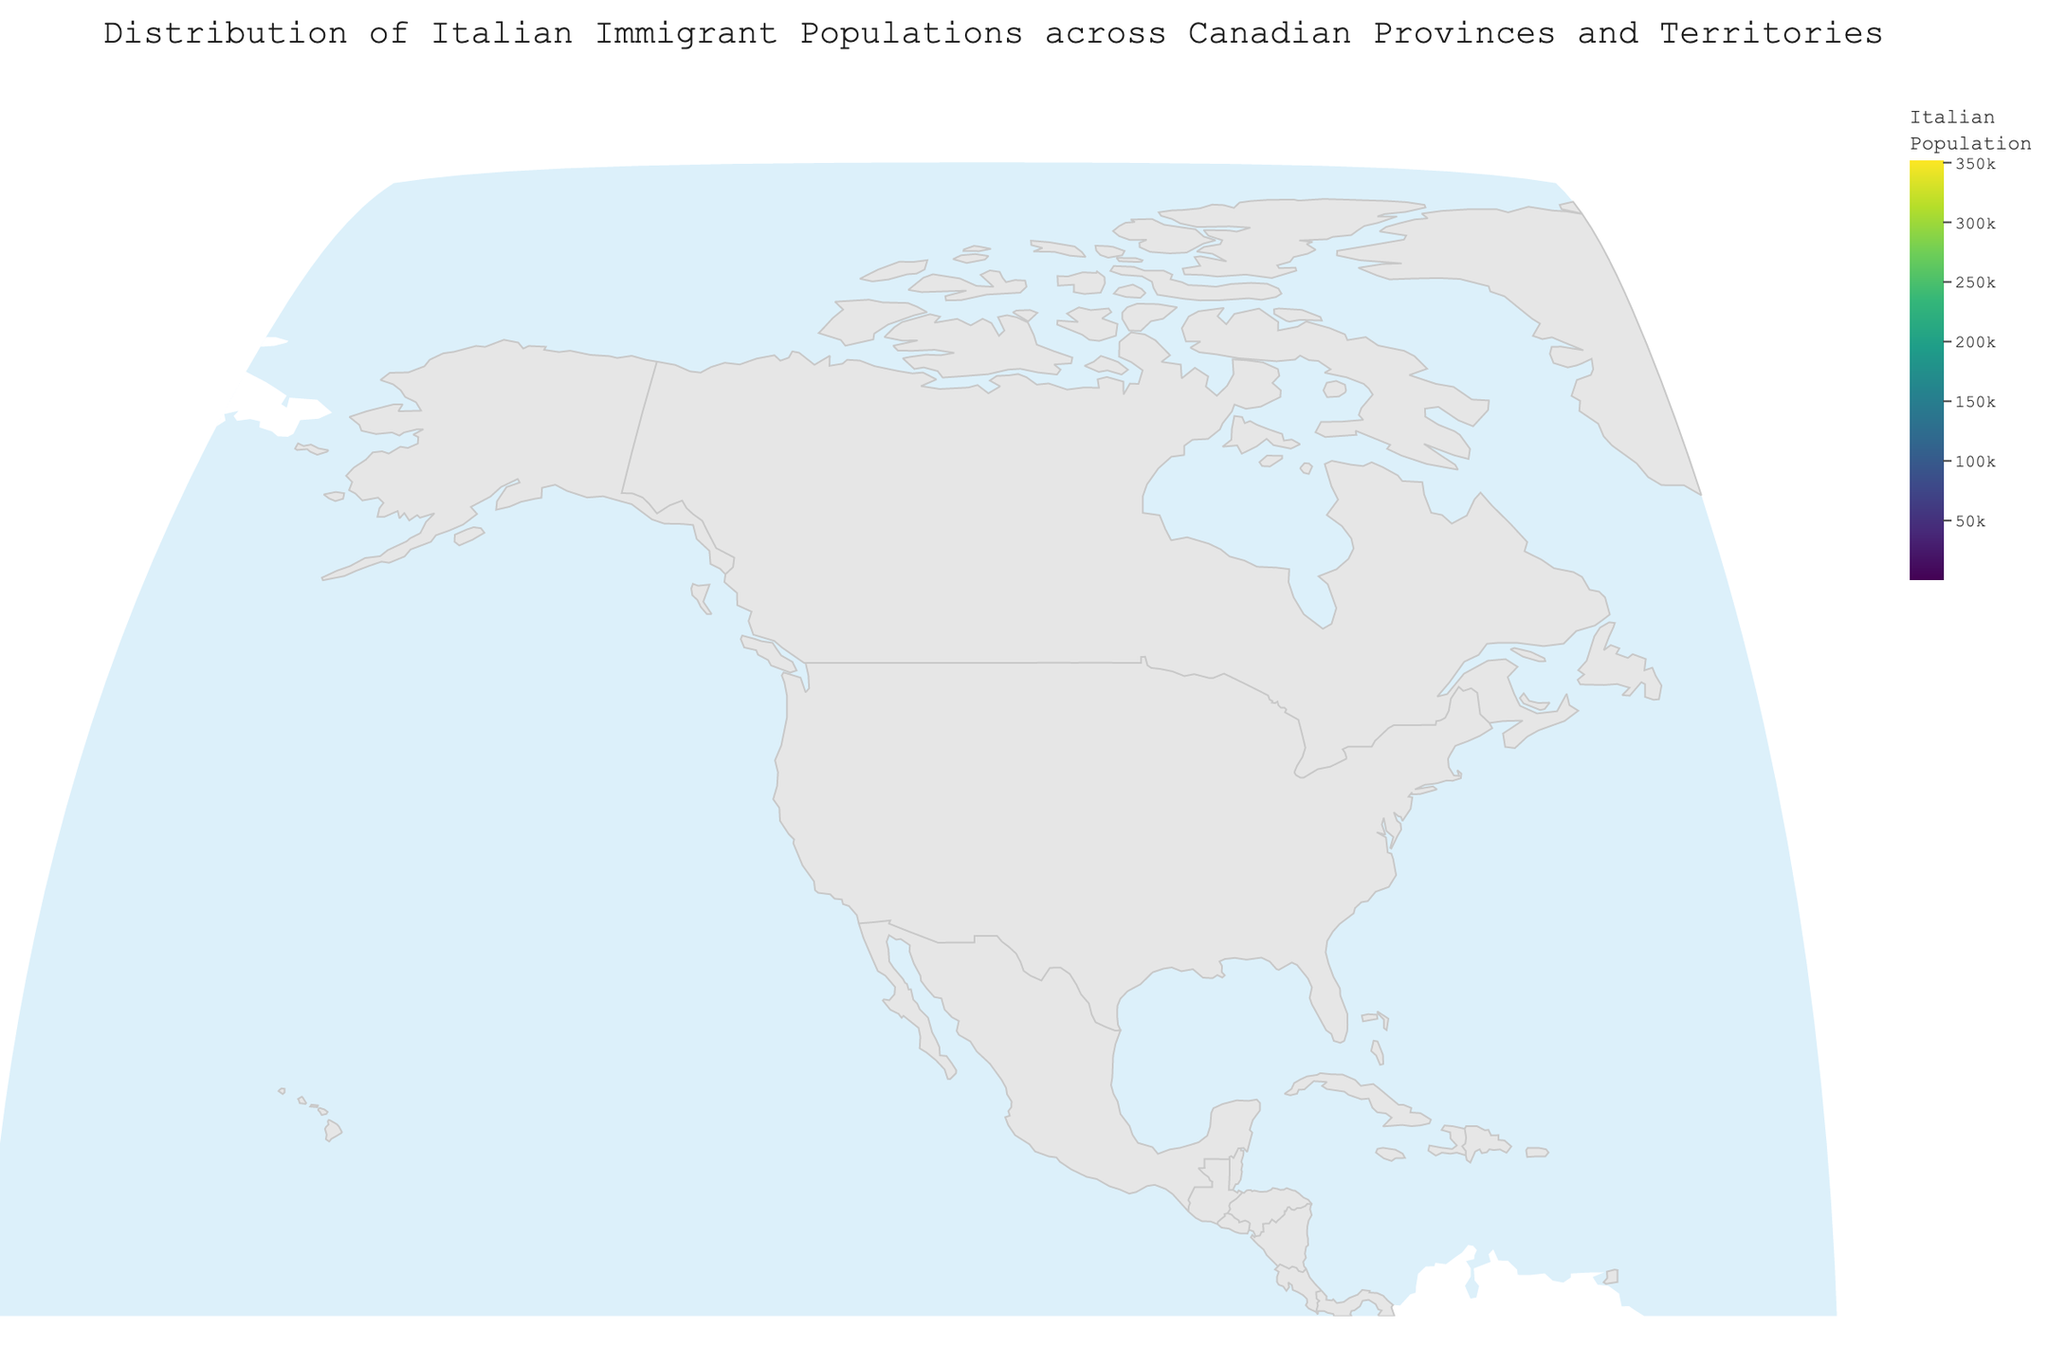Which province has the highest Italian immigrant population? By looking at the figure, it is evident that Ontario has the highest concentration of Italian immigrants with a population of 351,725.
Answer: Ontario What is the title of the figure? The title is often displayed prominently at the top of the figure. It reads "Distribution of Italian Immigrant Populations across Canadian Provinces and Territories."
Answer: Distribution of Italian Immigrant Populations across Canadian Provinces and Territories What is the sum of the Italian populations in British Columbia and Alberta? To find the total, add the populations of British Columbia (87,225) and Alberta (44,640): 87,225 + 44,640 = 131,865
Answer: 131,865 Which Canadian territory has the smallest number of Italian immigrants? By looking at the data shown in the figure, Nunavut has the smallest Italian immigrant population with only 95 people.
Answer: Nunavut How does the Italian population in Quebec compare to that in Newfoundland and Labrador? Quebec has 143,955 Italian immigrants, whereas Newfoundland and Labrador have only 1,785. Clearly, Quebec has a significantly higher Italian population compared to Newfoundland and Labrador.
Answer: Quebec has significantly more What is the average Italian population across all Canadian provinces and territories? To calculate the average, add the populations of all the provinces and territories and then divide by the number of regions (13). The total population is 657,380; hence, the average is 657,380 / 13 ≈ 50,566.
Answer: 50,566 Which provinces have Italian populations that are above 100,000? From the figure, Ontario (351,725) and Quebec (143,955) have Italian populations exceeding 100,000.
Answer: Ontario and Quebec What does the color scale represent in the figure? The color scale, shown as a color bar to the right of the figure, represents the 'Italian Population' with different shades indicating varying population sizes.
Answer: Italian Population In which provinces or territories is the Italian immigrant population less than 5,000? From the figure, this includes Saskatchewan (4,560), New Brunswick (3,215), Newfoundland and Labrador (1,785), Prince Edward Island (890), Yukon (425), Northwest Territories (315), and Nunavut (95).
Answer: Saskatchewan, New Brunswick, Newfoundland and Labrador, Prince Edward Island, Yukon, Northwest Territories, and Nunavut Are there more Italian immigrants in Manitoba or Nova Scotia, and by how much? Comparing the two provinces, Manitoba has 12,655 Italian immigrants while Nova Scotia has 7,895. The difference is 12,655 - 7,895 = 4,760.
Answer: Manitoba by 4,760 